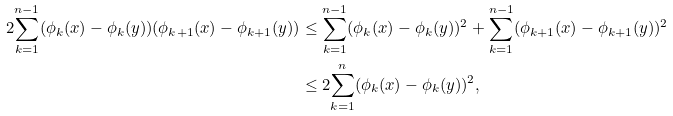Convert formula to latex. <formula><loc_0><loc_0><loc_500><loc_500>2 \overset { n - 1 } { \underset { k = 1 } { \sum } } ( \phi _ { k } ( x ) - \phi _ { k } ( y ) ) ( \phi _ { k + 1 } ( x ) - \phi _ { k + 1 } ( y ) ) & \leq \overset { n - 1 } { \underset { k = 1 } { \sum } } ( \phi _ { k } ( x ) - \phi _ { k } ( y ) ) ^ { 2 } + \overset { n - 1 } { \underset { k = 1 } { \sum } } ( \phi _ { k + 1 } ( x ) - \phi _ { k + 1 } ( y ) ) ^ { 2 } \\ & \leq 2 \overset { n } { \underset { k = 1 } { \sum } } ( \phi _ { k } ( x ) - \phi _ { k } ( y ) ) ^ { 2 } ,</formula> 